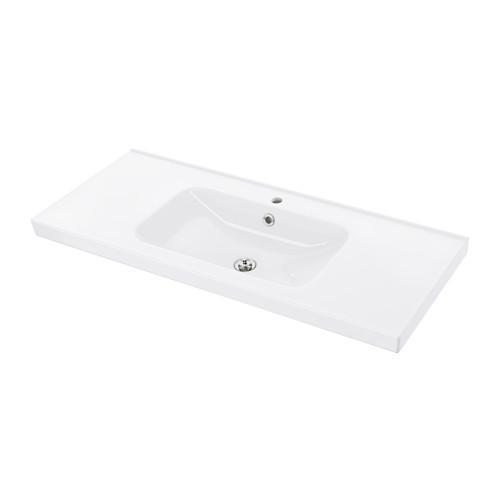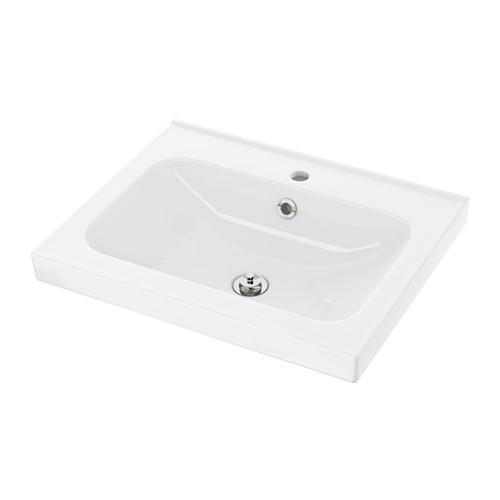The first image is the image on the left, the second image is the image on the right. Analyze the images presented: Is the assertion "There are two wash basins facing the same direction." valid? Answer yes or no. Yes. 